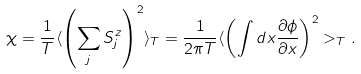<formula> <loc_0><loc_0><loc_500><loc_500>\chi = \frac { 1 } { T } \langle \left ( \sum _ { j } S ^ { z } _ { j } \right ) ^ { 2 } \rangle _ { T } = \frac { 1 } { 2 \pi T } \langle \left ( \int d x \frac { \partial \phi } { \partial x } \right ) ^ { 2 } > _ { T } .</formula> 